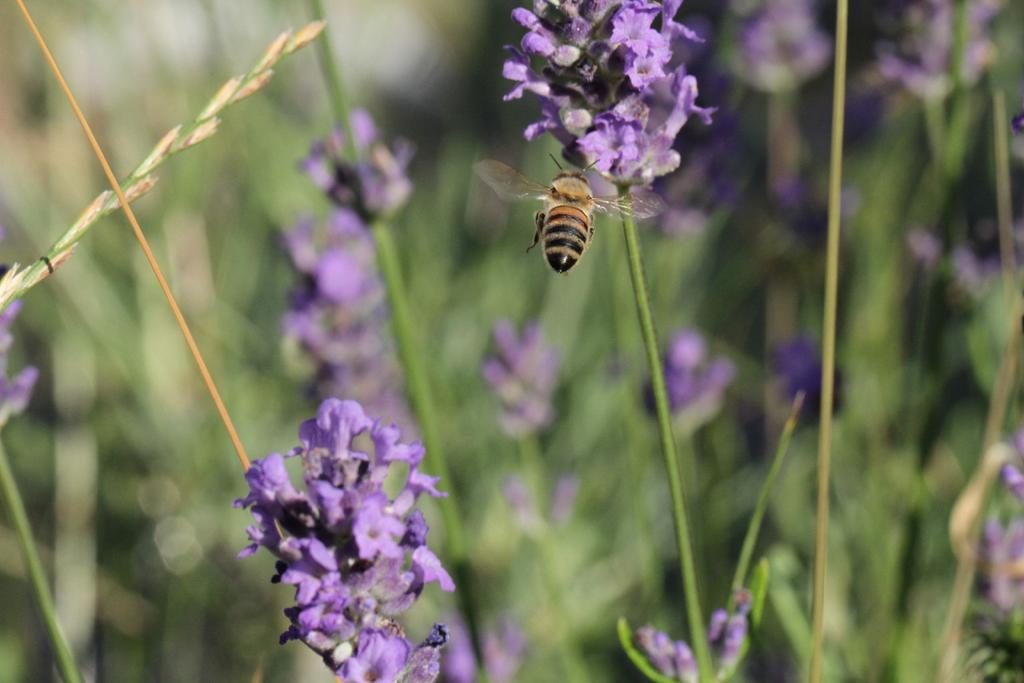What is the main subject in the center of the image? There is a honey bee in the center of the image. What is the honey bee interacting with in the image? The honey bee is interacting with a flower in the image. What else can be seen in the image besides the honey bee and flower? There are many plants in the image. How many snails are crawling on the honey bee's finger in the image? There are no snails or fingers present in the image; it features a honey bee interacting with a flower and surrounded by plants. 